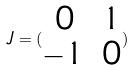<formula> <loc_0><loc_0><loc_500><loc_500>J = ( \begin{matrix} 0 & 1 \\ - 1 & 0 \end{matrix} )</formula> 